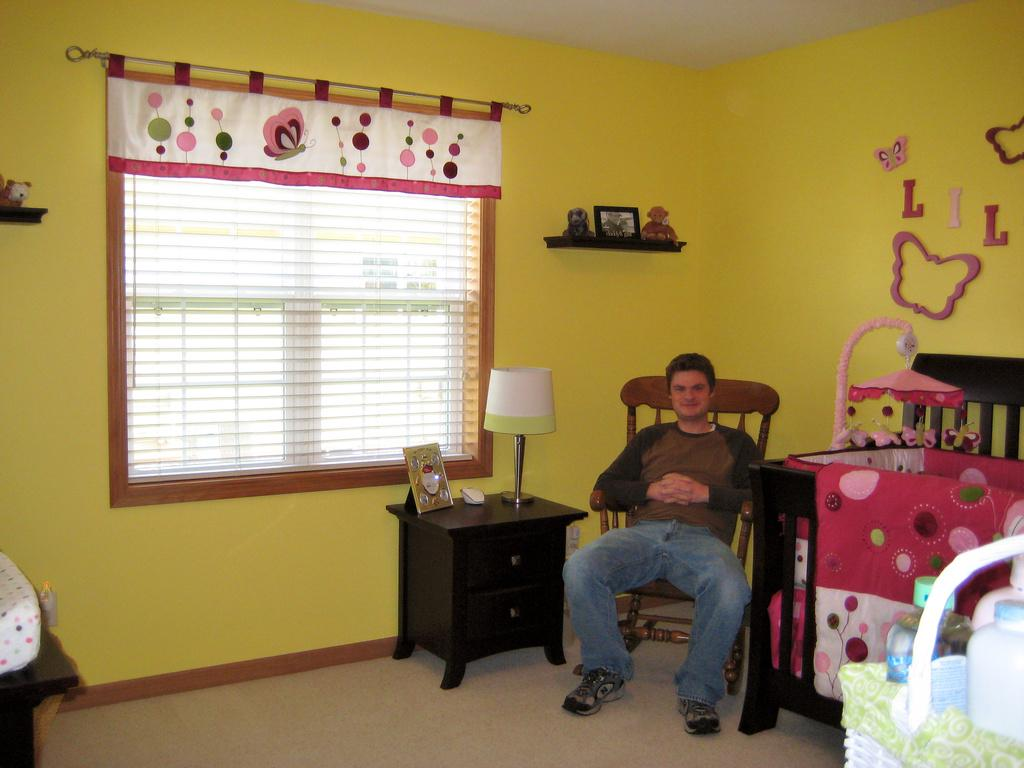What is the person in the image doing? The person is sitting on a chair in the image. What is located on the table in the image? There is a lamp and a photo frame on the table in the image. What can be seen in the background of the image? There is a sticker and a window in the background, and a curtain is associated with the window. What type of magic is the person performing in the image? There is no indication of magic or any magical activity in the image. 